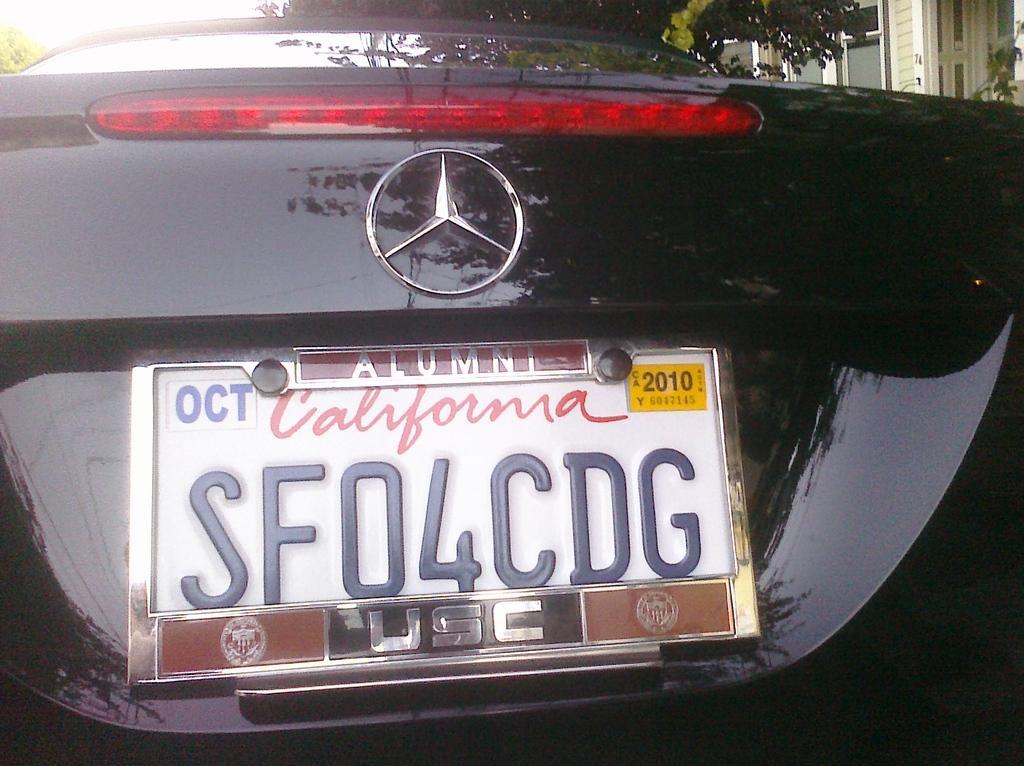How would you summarize this image in a sentence or two? In the center of the image we can see a car. On the car we can see a logo, board. On the board we can see the text. At the top of the image we can see the trees, windows, wall and sky. 